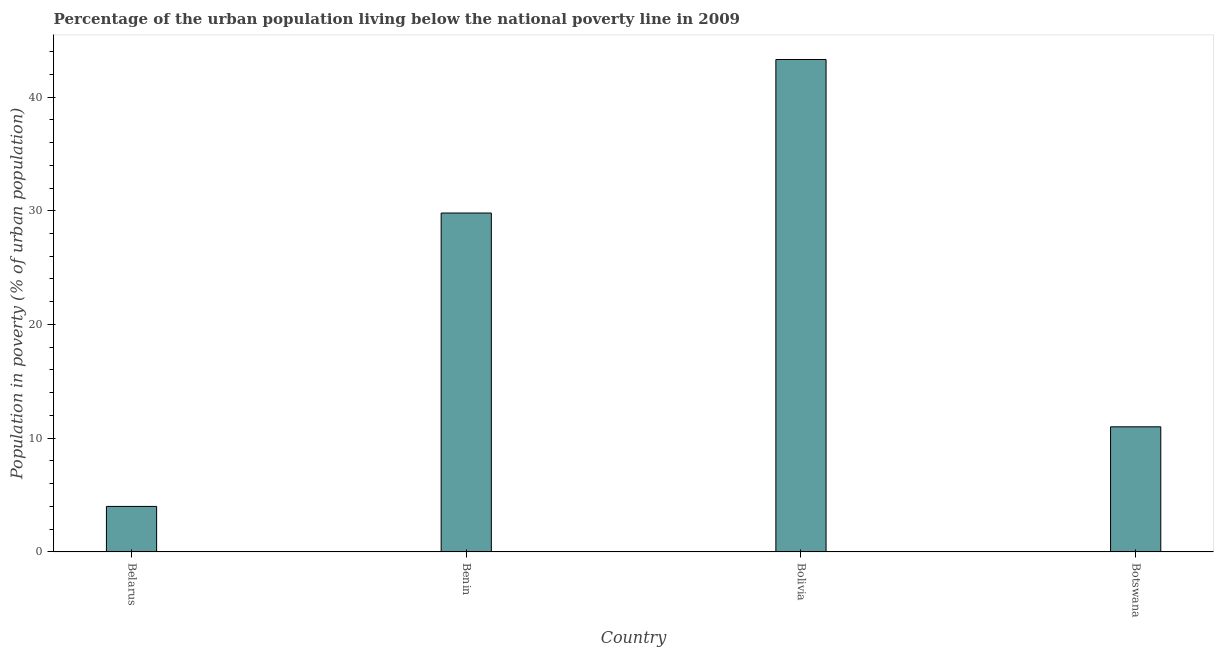Does the graph contain any zero values?
Give a very brief answer. No. What is the title of the graph?
Ensure brevity in your answer.  Percentage of the urban population living below the national poverty line in 2009. What is the label or title of the Y-axis?
Make the answer very short. Population in poverty (% of urban population). What is the percentage of urban population living below poverty line in Benin?
Offer a very short reply. 29.8. Across all countries, what is the maximum percentage of urban population living below poverty line?
Provide a short and direct response. 43.3. In which country was the percentage of urban population living below poverty line maximum?
Make the answer very short. Bolivia. In which country was the percentage of urban population living below poverty line minimum?
Your response must be concise. Belarus. What is the sum of the percentage of urban population living below poverty line?
Provide a succinct answer. 88.1. What is the difference between the percentage of urban population living below poverty line in Bolivia and Botswana?
Keep it short and to the point. 32.3. What is the average percentage of urban population living below poverty line per country?
Your answer should be very brief. 22.02. What is the median percentage of urban population living below poverty line?
Give a very brief answer. 20.4. In how many countries, is the percentage of urban population living below poverty line greater than 4 %?
Offer a very short reply. 3. What is the ratio of the percentage of urban population living below poverty line in Benin to that in Botswana?
Your answer should be compact. 2.71. Is the percentage of urban population living below poverty line in Benin less than that in Bolivia?
Your response must be concise. Yes. What is the difference between the highest and the second highest percentage of urban population living below poverty line?
Provide a short and direct response. 13.5. Is the sum of the percentage of urban population living below poverty line in Belarus and Benin greater than the maximum percentage of urban population living below poverty line across all countries?
Provide a succinct answer. No. What is the difference between the highest and the lowest percentage of urban population living below poverty line?
Make the answer very short. 39.3. How many bars are there?
Offer a very short reply. 4. Are all the bars in the graph horizontal?
Make the answer very short. No. How many countries are there in the graph?
Provide a short and direct response. 4. What is the Population in poverty (% of urban population) in Benin?
Give a very brief answer. 29.8. What is the Population in poverty (% of urban population) in Bolivia?
Provide a succinct answer. 43.3. What is the Population in poverty (% of urban population) in Botswana?
Your answer should be very brief. 11. What is the difference between the Population in poverty (% of urban population) in Belarus and Benin?
Your answer should be very brief. -25.8. What is the difference between the Population in poverty (% of urban population) in Belarus and Bolivia?
Provide a succinct answer. -39.3. What is the difference between the Population in poverty (% of urban population) in Belarus and Botswana?
Provide a short and direct response. -7. What is the difference between the Population in poverty (% of urban population) in Benin and Bolivia?
Ensure brevity in your answer.  -13.5. What is the difference between the Population in poverty (% of urban population) in Benin and Botswana?
Your answer should be compact. 18.8. What is the difference between the Population in poverty (% of urban population) in Bolivia and Botswana?
Your answer should be very brief. 32.3. What is the ratio of the Population in poverty (% of urban population) in Belarus to that in Benin?
Your answer should be compact. 0.13. What is the ratio of the Population in poverty (% of urban population) in Belarus to that in Bolivia?
Your response must be concise. 0.09. What is the ratio of the Population in poverty (% of urban population) in Belarus to that in Botswana?
Your response must be concise. 0.36. What is the ratio of the Population in poverty (% of urban population) in Benin to that in Bolivia?
Offer a terse response. 0.69. What is the ratio of the Population in poverty (% of urban population) in Benin to that in Botswana?
Ensure brevity in your answer.  2.71. What is the ratio of the Population in poverty (% of urban population) in Bolivia to that in Botswana?
Your answer should be compact. 3.94. 